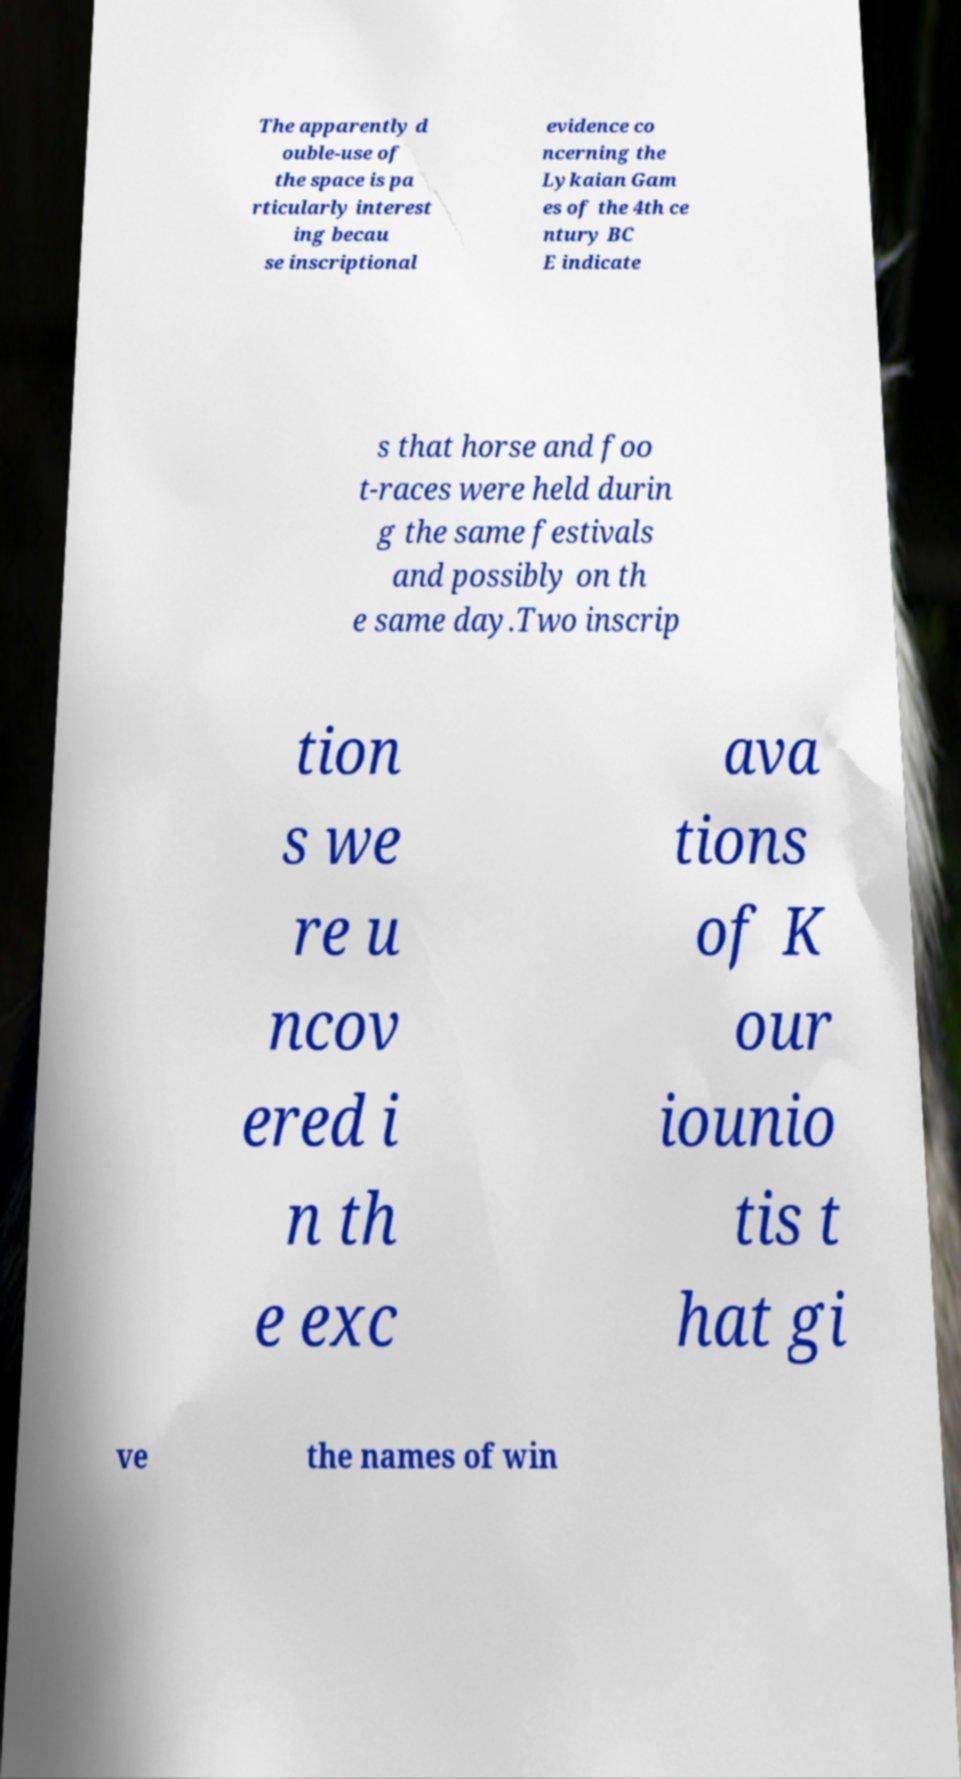Can you accurately transcribe the text from the provided image for me? The apparently d ouble-use of the space is pa rticularly interest ing becau se inscriptional evidence co ncerning the Lykaian Gam es of the 4th ce ntury BC E indicate s that horse and foo t-races were held durin g the same festivals and possibly on th e same day.Two inscrip tion s we re u ncov ered i n th e exc ava tions of K our iounio tis t hat gi ve the names of win 